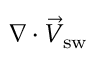<formula> <loc_0><loc_0><loc_500><loc_500>\nabla \cdot \vec { V } _ { s w }</formula> 